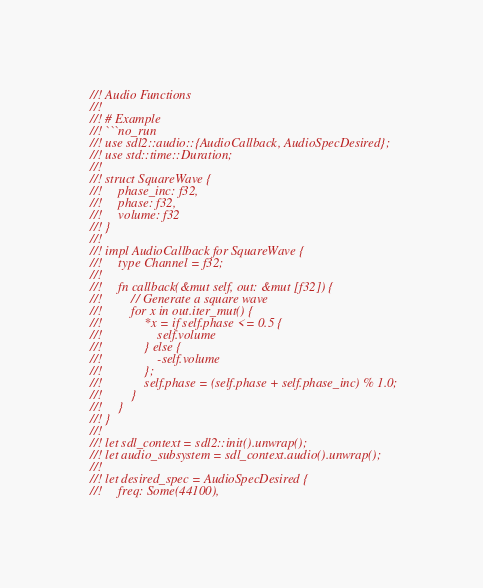<code> <loc_0><loc_0><loc_500><loc_500><_Rust_>//! Audio Functions
//!
//! # Example
//! ```no_run
//! use sdl2::audio::{AudioCallback, AudioSpecDesired};
//! use std::time::Duration;
//!
//! struct SquareWave {
//!     phase_inc: f32,
//!     phase: f32,
//!     volume: f32
//! }
//!
//! impl AudioCallback for SquareWave {
//!     type Channel = f32;
//!
//!     fn callback(&mut self, out: &mut [f32]) {
//!         // Generate a square wave
//!         for x in out.iter_mut() {
//!             *x = if self.phase <= 0.5 {
//!                 self.volume
//!             } else {
//!                 -self.volume
//!             };
//!             self.phase = (self.phase + self.phase_inc) % 1.0;
//!         }
//!     }
//! }
//!
//! let sdl_context = sdl2::init().unwrap();
//! let audio_subsystem = sdl_context.audio().unwrap();
//!
//! let desired_spec = AudioSpecDesired {
//!     freq: Some(44100),</code> 